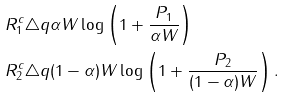Convert formula to latex. <formula><loc_0><loc_0><loc_500><loc_500>& R _ { 1 } ^ { c } \triangle q \alpha W \log \left ( 1 + \frac { P _ { 1 } } { \alpha W } \right ) \\ & R _ { 2 } ^ { c } \triangle q ( 1 - \alpha ) W \log \left ( 1 + \frac { P _ { 2 } } { ( 1 - \alpha ) W } \right ) .</formula> 